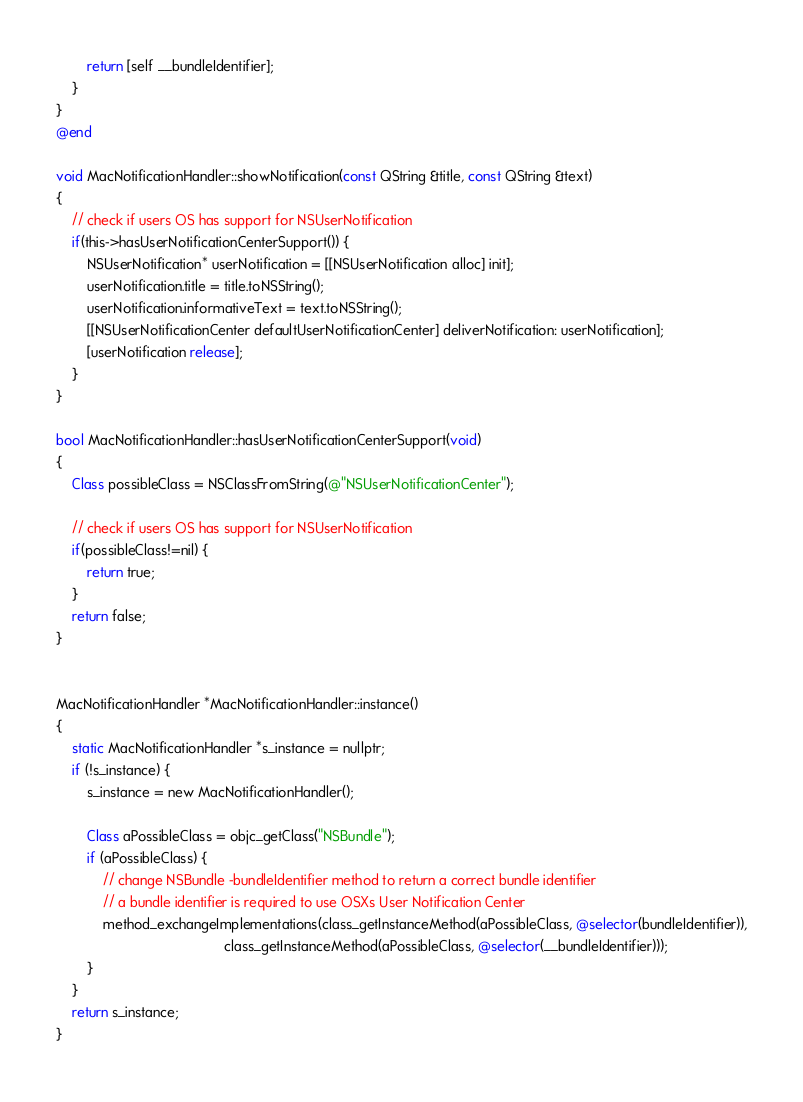<code> <loc_0><loc_0><loc_500><loc_500><_ObjectiveC_>        return [self __bundleIdentifier];
    }
}
@end

void MacNotificationHandler::showNotification(const QString &title, const QString &text)
{
    // check if users OS has support for NSUserNotification
    if(this->hasUserNotificationCenterSupport()) {
        NSUserNotification* userNotification = [[NSUserNotification alloc] init];
        userNotification.title = title.toNSString();
        userNotification.informativeText = text.toNSString();
        [[NSUserNotificationCenter defaultUserNotificationCenter] deliverNotification: userNotification];
        [userNotification release];
    }
}

bool MacNotificationHandler::hasUserNotificationCenterSupport(void)
{
    Class possibleClass = NSClassFromString(@"NSUserNotificationCenter");

    // check if users OS has support for NSUserNotification
    if(possibleClass!=nil) {
        return true;
    }
    return false;
}


MacNotificationHandler *MacNotificationHandler::instance()
{
    static MacNotificationHandler *s_instance = nullptr;
    if (!s_instance) {
        s_instance = new MacNotificationHandler();

        Class aPossibleClass = objc_getClass("NSBundle");
        if (aPossibleClass) {
            // change NSBundle -bundleIdentifier method to return a correct bundle identifier
            // a bundle identifier is required to use OSXs User Notification Center
            method_exchangeImplementations(class_getInstanceMethod(aPossibleClass, @selector(bundleIdentifier)),
                                           class_getInstanceMethod(aPossibleClass, @selector(__bundleIdentifier)));
        }
    }
    return s_instance;
}
</code> 